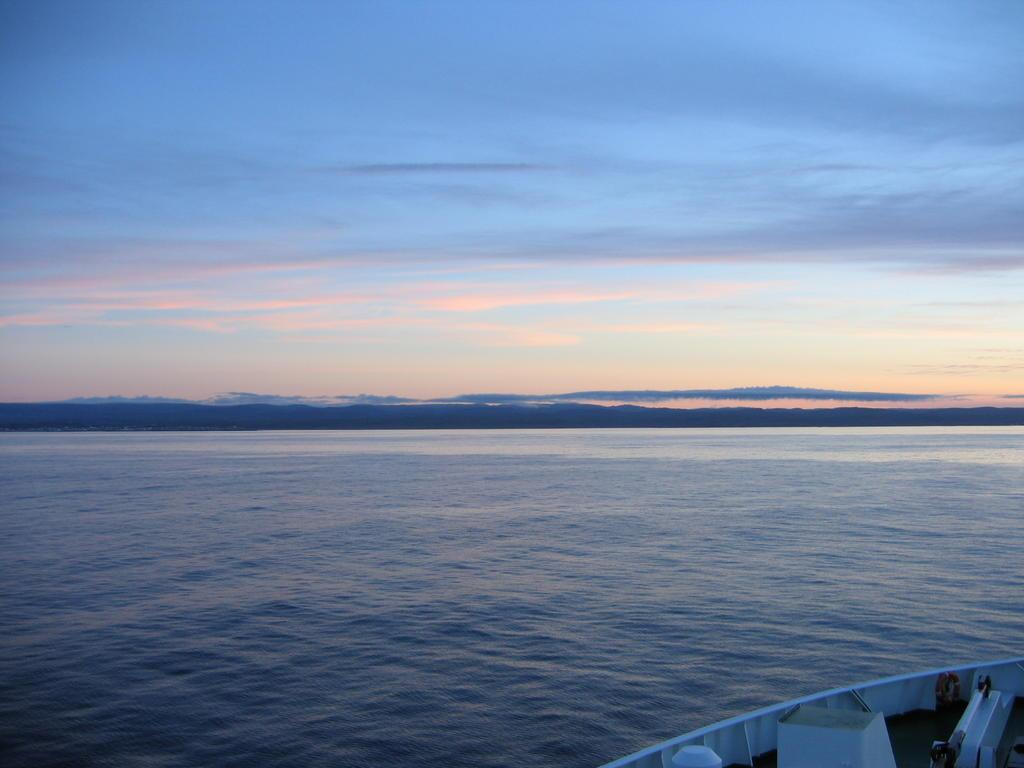What is the primary element visible in the image? There is water in the image. What else can be seen in the image besides the water? There is an object in the image. What can be seen in the background of the image? The sky is visible in the background of the image. What type of bun is being used to measure the temperature of the water in the image? There is no bun present in the image, nor is there any indication of temperature measurement. 